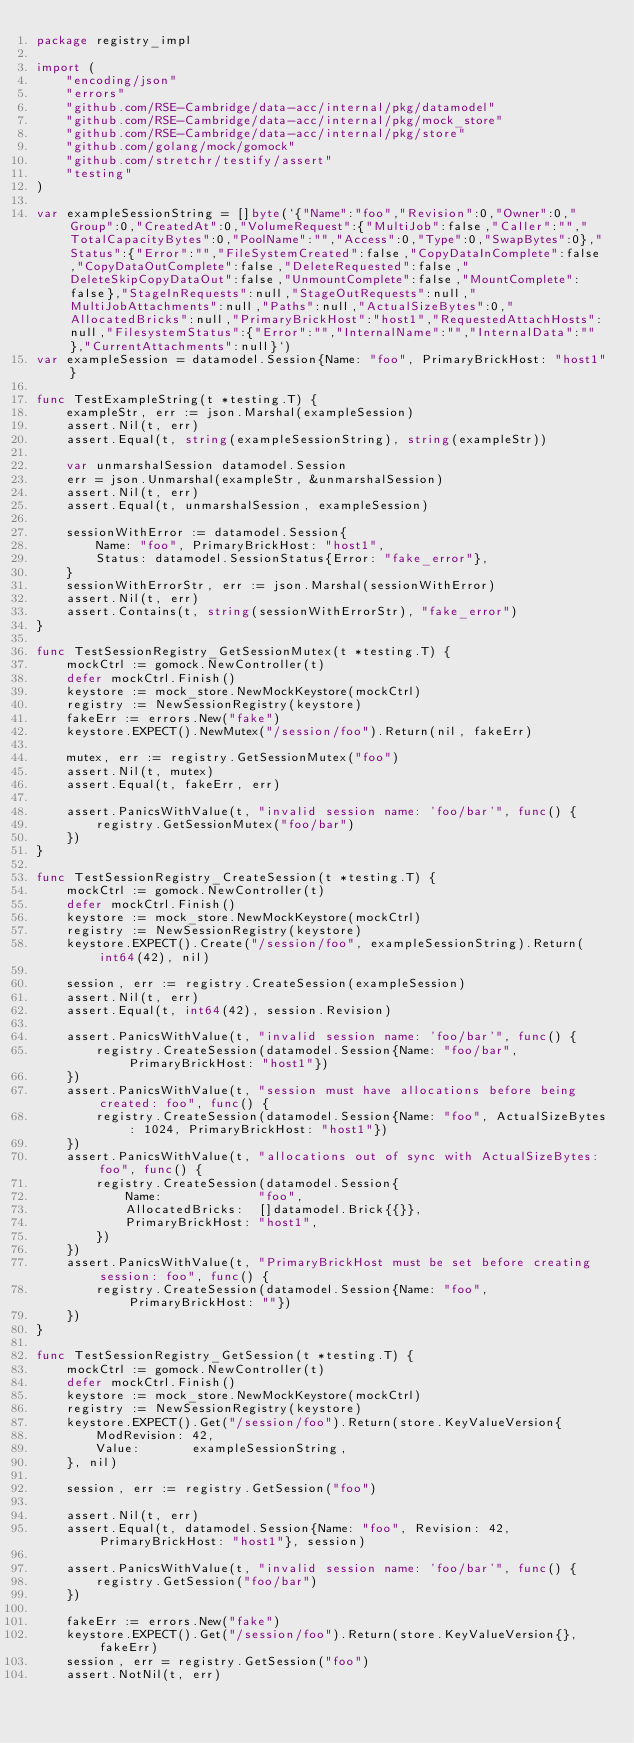Convert code to text. <code><loc_0><loc_0><loc_500><loc_500><_Go_>package registry_impl

import (
	"encoding/json"
	"errors"
	"github.com/RSE-Cambridge/data-acc/internal/pkg/datamodel"
	"github.com/RSE-Cambridge/data-acc/internal/pkg/mock_store"
	"github.com/RSE-Cambridge/data-acc/internal/pkg/store"
	"github.com/golang/mock/gomock"
	"github.com/stretchr/testify/assert"
	"testing"
)

var exampleSessionString = []byte(`{"Name":"foo","Revision":0,"Owner":0,"Group":0,"CreatedAt":0,"VolumeRequest":{"MultiJob":false,"Caller":"","TotalCapacityBytes":0,"PoolName":"","Access":0,"Type":0,"SwapBytes":0},"Status":{"Error":"","FileSystemCreated":false,"CopyDataInComplete":false,"CopyDataOutComplete":false,"DeleteRequested":false,"DeleteSkipCopyDataOut":false,"UnmountComplete":false,"MountComplete":false},"StageInRequests":null,"StageOutRequests":null,"MultiJobAttachments":null,"Paths":null,"ActualSizeBytes":0,"AllocatedBricks":null,"PrimaryBrickHost":"host1","RequestedAttachHosts":null,"FilesystemStatus":{"Error":"","InternalName":"","InternalData":""},"CurrentAttachments":null}`)
var exampleSession = datamodel.Session{Name: "foo", PrimaryBrickHost: "host1"}

func TestExampleString(t *testing.T) {
	exampleStr, err := json.Marshal(exampleSession)
	assert.Nil(t, err)
	assert.Equal(t, string(exampleSessionString), string(exampleStr))

	var unmarshalSession datamodel.Session
	err = json.Unmarshal(exampleStr, &unmarshalSession)
	assert.Nil(t, err)
	assert.Equal(t, unmarshalSession, exampleSession)

	sessionWithError := datamodel.Session{
		Name: "foo", PrimaryBrickHost: "host1",
		Status: datamodel.SessionStatus{Error: "fake_error"},
	}
	sessionWithErrorStr, err := json.Marshal(sessionWithError)
	assert.Nil(t, err)
	assert.Contains(t, string(sessionWithErrorStr), "fake_error")
}

func TestSessionRegistry_GetSessionMutex(t *testing.T) {
	mockCtrl := gomock.NewController(t)
	defer mockCtrl.Finish()
	keystore := mock_store.NewMockKeystore(mockCtrl)
	registry := NewSessionRegistry(keystore)
	fakeErr := errors.New("fake")
	keystore.EXPECT().NewMutex("/session/foo").Return(nil, fakeErr)

	mutex, err := registry.GetSessionMutex("foo")
	assert.Nil(t, mutex)
	assert.Equal(t, fakeErr, err)

	assert.PanicsWithValue(t, "invalid session name: 'foo/bar'", func() {
		registry.GetSessionMutex("foo/bar")
	})
}

func TestSessionRegistry_CreateSession(t *testing.T) {
	mockCtrl := gomock.NewController(t)
	defer mockCtrl.Finish()
	keystore := mock_store.NewMockKeystore(mockCtrl)
	registry := NewSessionRegistry(keystore)
	keystore.EXPECT().Create("/session/foo", exampleSessionString).Return(int64(42), nil)

	session, err := registry.CreateSession(exampleSession)
	assert.Nil(t, err)
	assert.Equal(t, int64(42), session.Revision)

	assert.PanicsWithValue(t, "invalid session name: 'foo/bar'", func() {
		registry.CreateSession(datamodel.Session{Name: "foo/bar", PrimaryBrickHost: "host1"})
	})
	assert.PanicsWithValue(t, "session must have allocations before being created: foo", func() {
		registry.CreateSession(datamodel.Session{Name: "foo", ActualSizeBytes: 1024, PrimaryBrickHost: "host1"})
	})
	assert.PanicsWithValue(t, "allocations out of sync with ActualSizeBytes: foo", func() {
		registry.CreateSession(datamodel.Session{
			Name:             "foo",
			AllocatedBricks:  []datamodel.Brick{{}},
			PrimaryBrickHost: "host1",
		})
	})
	assert.PanicsWithValue(t, "PrimaryBrickHost must be set before creating session: foo", func() {
		registry.CreateSession(datamodel.Session{Name: "foo", PrimaryBrickHost: ""})
	})
}

func TestSessionRegistry_GetSession(t *testing.T) {
	mockCtrl := gomock.NewController(t)
	defer mockCtrl.Finish()
	keystore := mock_store.NewMockKeystore(mockCtrl)
	registry := NewSessionRegistry(keystore)
	keystore.EXPECT().Get("/session/foo").Return(store.KeyValueVersion{
		ModRevision: 42,
		Value:       exampleSessionString,
	}, nil)

	session, err := registry.GetSession("foo")

	assert.Nil(t, err)
	assert.Equal(t, datamodel.Session{Name: "foo", Revision: 42, PrimaryBrickHost: "host1"}, session)

	assert.PanicsWithValue(t, "invalid session name: 'foo/bar'", func() {
		registry.GetSession("foo/bar")
	})

	fakeErr := errors.New("fake")
	keystore.EXPECT().Get("/session/foo").Return(store.KeyValueVersion{}, fakeErr)
	session, err = registry.GetSession("foo")
	assert.NotNil(t, err)</code> 